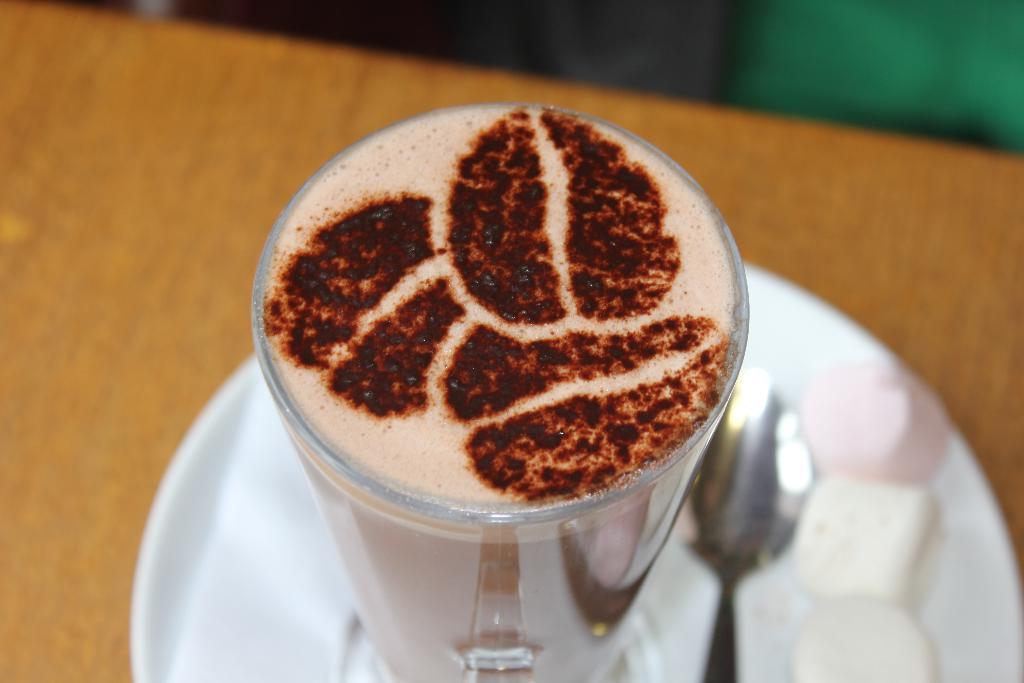Can you describe this image briefly? In this image we can see a glass with some drink and coffee art at the top of the glass, spoon, white color food item on the plate, there we can also see a table where the plate is located on it. 